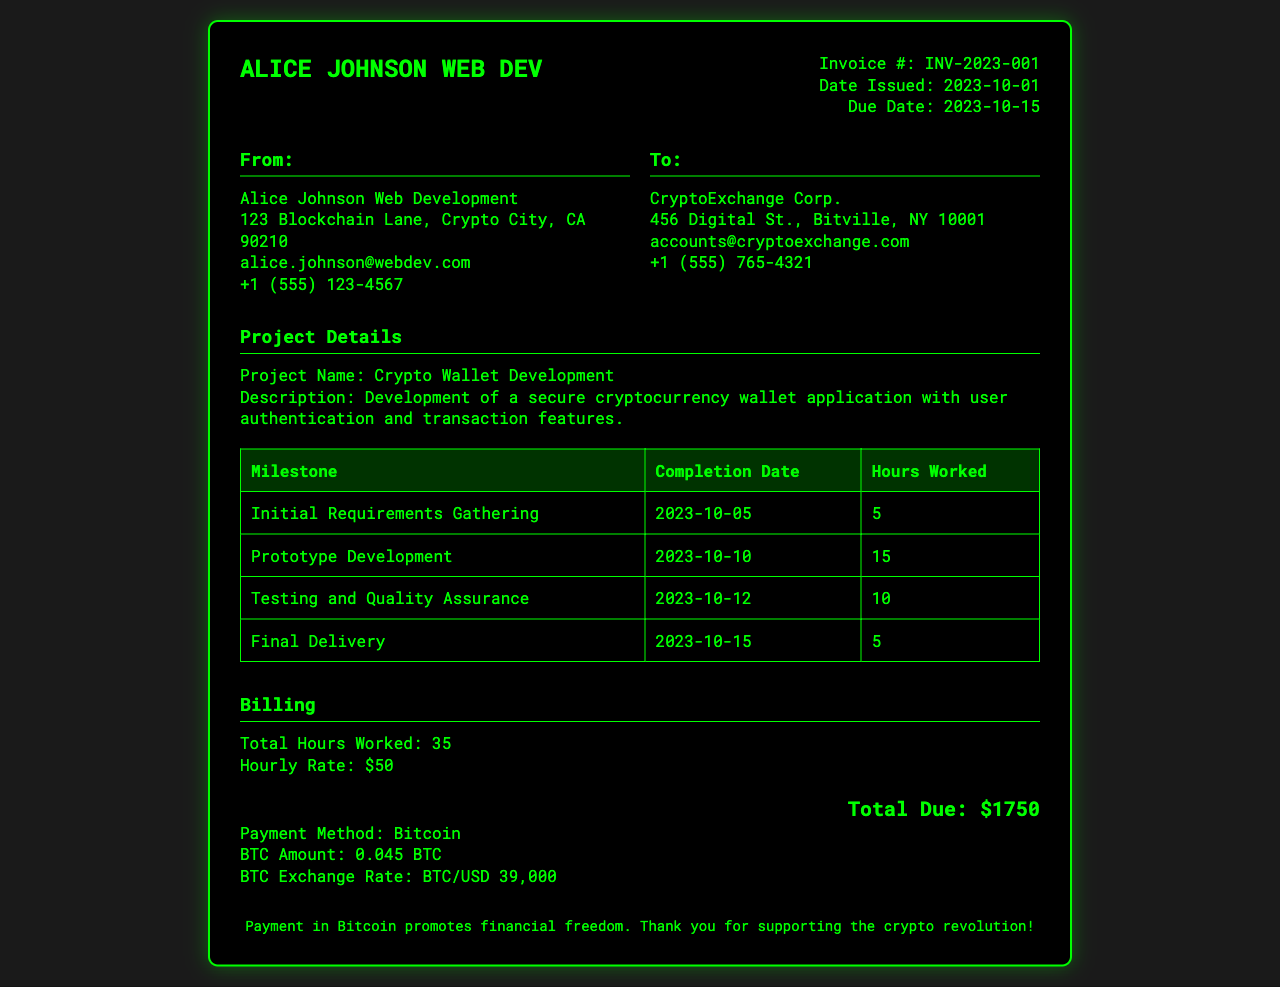What is the invoice number? The invoice number is listed at the top of the document under invoice details.
Answer: INV-2023-001 Who is the client? The client is mentioned in the "To" section of the invoice.
Answer: CryptoExchange Corp What is the complete address of the service provider? The complete address is listed in the "From" section of the invoice.
Answer: 123 Blockchain Lane, Crypto City, CA 90210 What is the total number of hours worked? The total hours worked is calculated based on the milestones listed in the project details.
Answer: 35 When is the payment due? The due date is specified in the invoice details section.
Answer: 2023-10-15 What is the payment method accepted? The payment method is indicated in the billing section of the invoice.
Answer: Bitcoin What is the hourly rate for the services? The hourly rate is mentioned in the billing section of the invoice.
Answer: $50 What was the completion date for the "Prototype Development" milestone? The completion date for this milestone is provided in the project details table.
Answer: 2023-10-10 How much is the total due in Bitcoin? The total due amount is specified in the billing section of the invoice.
Answer: 0.045 BTC 